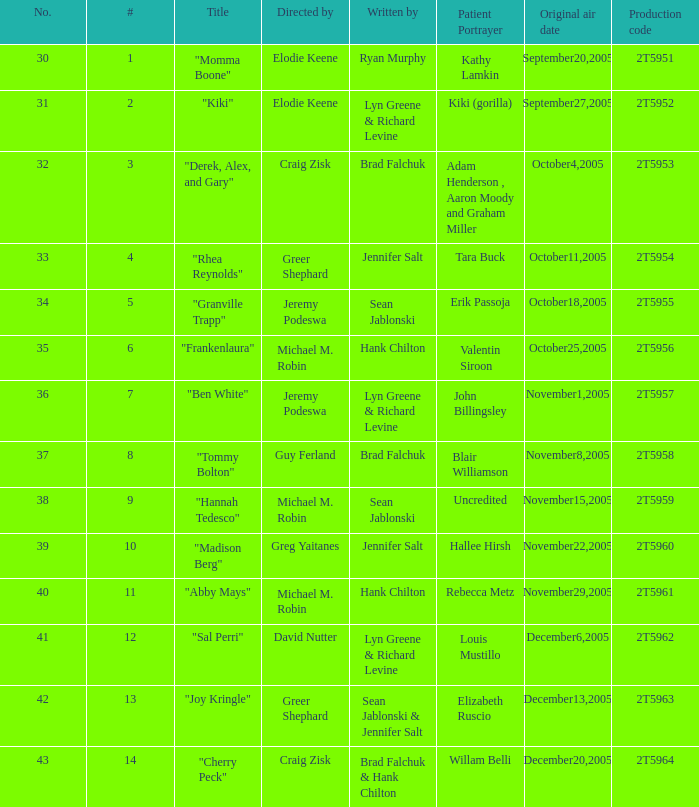Parse the full table. {'header': ['No.', '#', 'Title', 'Directed by', 'Written by', 'Patient Portrayer', 'Original air date', 'Production code'], 'rows': [['30', '1', '"Momma Boone"', 'Elodie Keene', 'Ryan Murphy', 'Kathy Lamkin', 'September20,2005', '2T5951'], ['31', '2', '"Kiki"', 'Elodie Keene', 'Lyn Greene & Richard Levine', 'Kiki (gorilla)', 'September27,2005', '2T5952'], ['32', '3', '"Derek, Alex, and Gary"', 'Craig Zisk', 'Brad Falchuk', 'Adam Henderson , Aaron Moody and Graham Miller', 'October4,2005', '2T5953'], ['33', '4', '"Rhea Reynolds"', 'Greer Shephard', 'Jennifer Salt', 'Tara Buck', 'October11,2005', '2T5954'], ['34', '5', '"Granville Trapp"', 'Jeremy Podeswa', 'Sean Jablonski', 'Erik Passoja', 'October18,2005', '2T5955'], ['35', '6', '"Frankenlaura"', 'Michael M. Robin', 'Hank Chilton', 'Valentin Siroon', 'October25,2005', '2T5956'], ['36', '7', '"Ben White"', 'Jeremy Podeswa', 'Lyn Greene & Richard Levine', 'John Billingsley', 'November1,2005', '2T5957'], ['37', '8', '"Tommy Bolton"', 'Guy Ferland', 'Brad Falchuk', 'Blair Williamson', 'November8,2005', '2T5958'], ['38', '9', '"Hannah Tedesco"', 'Michael M. Robin', 'Sean Jablonski', 'Uncredited', 'November15,2005', '2T5959'], ['39', '10', '"Madison Berg"', 'Greg Yaitanes', 'Jennifer Salt', 'Hallee Hirsh', 'November22,2005', '2T5960'], ['40', '11', '"Abby Mays"', 'Michael M. Robin', 'Hank Chilton', 'Rebecca Metz', 'November29,2005', '2T5961'], ['41', '12', '"Sal Perri"', 'David Nutter', 'Lyn Greene & Richard Levine', 'Louis Mustillo', 'December6,2005', '2T5962'], ['42', '13', '"Joy Kringle"', 'Greer Shephard', 'Sean Jablonski & Jennifer Salt', 'Elizabeth Ruscio', 'December13,2005', '2T5963'], ['43', '14', '"Cherry Peck"', 'Craig Zisk', 'Brad Falchuk & Hank Chilton', 'Willam Belli', 'December20,2005', '2T5964']]} Who is the author of the episode with the production code 2t5954? Jennifer Salt. 